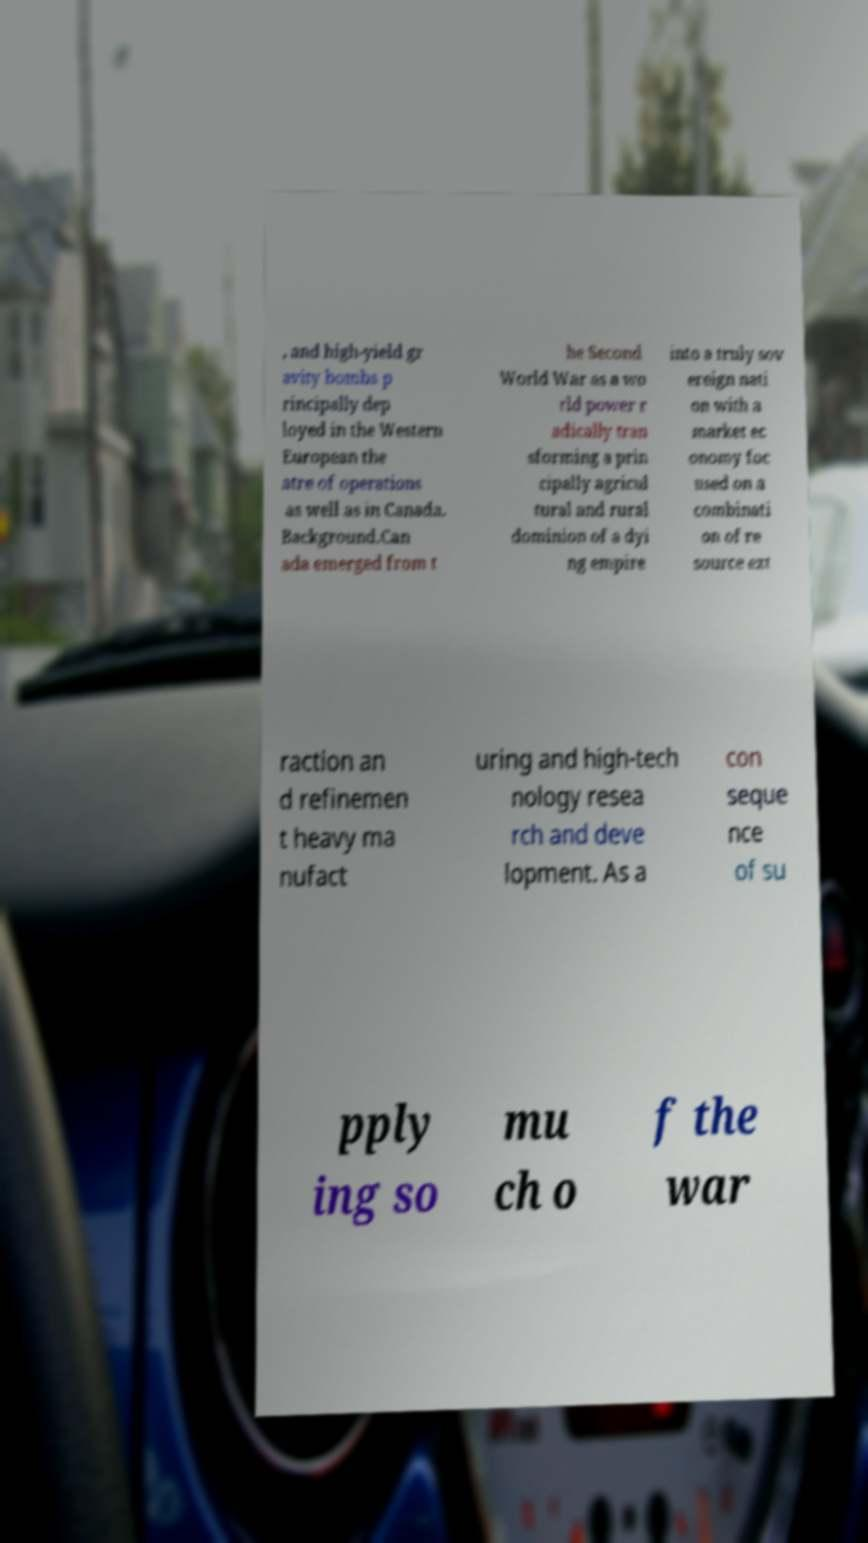Can you read and provide the text displayed in the image?This photo seems to have some interesting text. Can you extract and type it out for me? , and high-yield gr avity bombs p rincipally dep loyed in the Western European the atre of operations as well as in Canada. Background.Can ada emerged from t he Second World War as a wo rld power r adically tran sforming a prin cipally agricul tural and rural dominion of a dyi ng empire into a truly sov ereign nati on with a market ec onomy foc used on a combinati on of re source ext raction an d refinemen t heavy ma nufact uring and high-tech nology resea rch and deve lopment. As a con seque nce of su pply ing so mu ch o f the war 